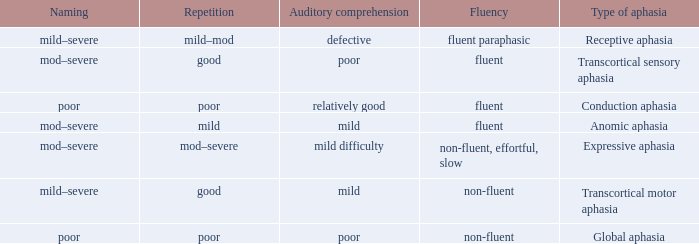Name the naming for fluent and poor comprehension Mod–severe. 